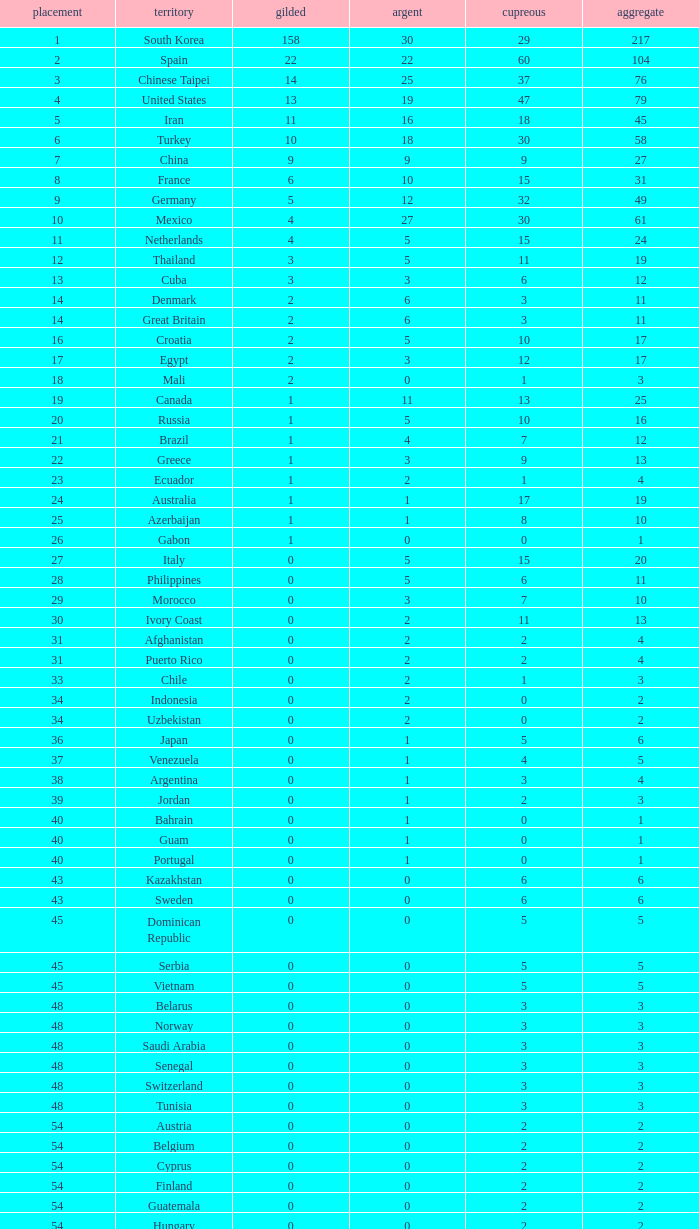What is the Total medals for the Nation ranking 33 with more than 1 Bronze? None. 